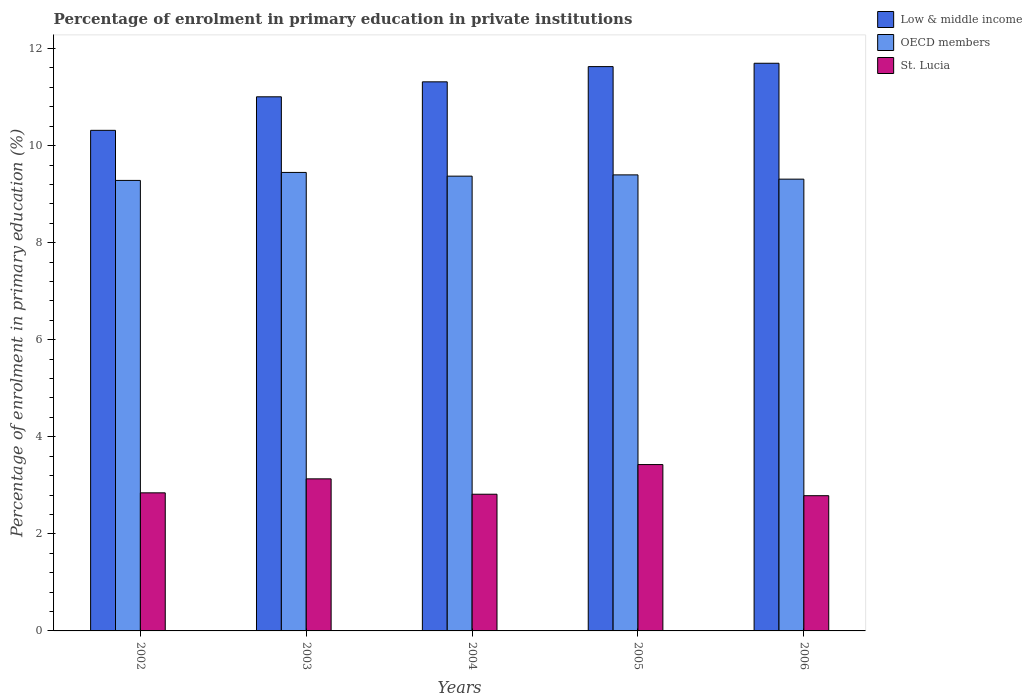How many different coloured bars are there?
Your answer should be very brief. 3. How many groups of bars are there?
Keep it short and to the point. 5. How many bars are there on the 1st tick from the left?
Your answer should be compact. 3. What is the label of the 2nd group of bars from the left?
Offer a very short reply. 2003. In how many cases, is the number of bars for a given year not equal to the number of legend labels?
Provide a succinct answer. 0. What is the percentage of enrolment in primary education in St. Lucia in 2004?
Your answer should be very brief. 2.82. Across all years, what is the maximum percentage of enrolment in primary education in OECD members?
Ensure brevity in your answer.  9.45. Across all years, what is the minimum percentage of enrolment in primary education in Low & middle income?
Your answer should be very brief. 10.31. What is the total percentage of enrolment in primary education in St. Lucia in the graph?
Make the answer very short. 15.01. What is the difference between the percentage of enrolment in primary education in OECD members in 2003 and that in 2006?
Give a very brief answer. 0.14. What is the difference between the percentage of enrolment in primary education in Low & middle income in 2003 and the percentage of enrolment in primary education in St. Lucia in 2005?
Keep it short and to the point. 7.58. What is the average percentage of enrolment in primary education in OECD members per year?
Your answer should be very brief. 9.36. In the year 2003, what is the difference between the percentage of enrolment in primary education in OECD members and percentage of enrolment in primary education in St. Lucia?
Provide a succinct answer. 6.31. In how many years, is the percentage of enrolment in primary education in Low & middle income greater than 7.2 %?
Your response must be concise. 5. What is the ratio of the percentage of enrolment in primary education in Low & middle income in 2004 to that in 2005?
Give a very brief answer. 0.97. Is the percentage of enrolment in primary education in Low & middle income in 2002 less than that in 2005?
Keep it short and to the point. Yes. What is the difference between the highest and the second highest percentage of enrolment in primary education in Low & middle income?
Your answer should be very brief. 0.07. What is the difference between the highest and the lowest percentage of enrolment in primary education in OECD members?
Provide a succinct answer. 0.16. In how many years, is the percentage of enrolment in primary education in St. Lucia greater than the average percentage of enrolment in primary education in St. Lucia taken over all years?
Ensure brevity in your answer.  2. What does the 3rd bar from the left in 2003 represents?
Offer a terse response. St. Lucia. Is it the case that in every year, the sum of the percentage of enrolment in primary education in St. Lucia and percentage of enrolment in primary education in Low & middle income is greater than the percentage of enrolment in primary education in OECD members?
Give a very brief answer. Yes. How many bars are there?
Provide a succinct answer. 15. How many years are there in the graph?
Offer a very short reply. 5. What is the difference between two consecutive major ticks on the Y-axis?
Ensure brevity in your answer.  2. Does the graph contain grids?
Offer a terse response. No. Where does the legend appear in the graph?
Make the answer very short. Top right. How are the legend labels stacked?
Provide a succinct answer. Vertical. What is the title of the graph?
Your answer should be very brief. Percentage of enrolment in primary education in private institutions. Does "Somalia" appear as one of the legend labels in the graph?
Give a very brief answer. No. What is the label or title of the Y-axis?
Provide a short and direct response. Percentage of enrolment in primary education (%). What is the Percentage of enrolment in primary education (%) of Low & middle income in 2002?
Your response must be concise. 10.31. What is the Percentage of enrolment in primary education (%) in OECD members in 2002?
Offer a terse response. 9.28. What is the Percentage of enrolment in primary education (%) of St. Lucia in 2002?
Offer a terse response. 2.85. What is the Percentage of enrolment in primary education (%) in Low & middle income in 2003?
Provide a short and direct response. 11.01. What is the Percentage of enrolment in primary education (%) in OECD members in 2003?
Offer a terse response. 9.45. What is the Percentage of enrolment in primary education (%) in St. Lucia in 2003?
Ensure brevity in your answer.  3.13. What is the Percentage of enrolment in primary education (%) in Low & middle income in 2004?
Your answer should be very brief. 11.31. What is the Percentage of enrolment in primary education (%) in OECD members in 2004?
Your response must be concise. 9.37. What is the Percentage of enrolment in primary education (%) in St. Lucia in 2004?
Give a very brief answer. 2.82. What is the Percentage of enrolment in primary education (%) in Low & middle income in 2005?
Give a very brief answer. 11.63. What is the Percentage of enrolment in primary education (%) of OECD members in 2005?
Provide a succinct answer. 9.4. What is the Percentage of enrolment in primary education (%) of St. Lucia in 2005?
Your answer should be compact. 3.43. What is the Percentage of enrolment in primary education (%) of Low & middle income in 2006?
Give a very brief answer. 11.7. What is the Percentage of enrolment in primary education (%) in OECD members in 2006?
Your answer should be compact. 9.31. What is the Percentage of enrolment in primary education (%) in St. Lucia in 2006?
Ensure brevity in your answer.  2.79. Across all years, what is the maximum Percentage of enrolment in primary education (%) of Low & middle income?
Ensure brevity in your answer.  11.7. Across all years, what is the maximum Percentage of enrolment in primary education (%) in OECD members?
Your answer should be very brief. 9.45. Across all years, what is the maximum Percentage of enrolment in primary education (%) of St. Lucia?
Give a very brief answer. 3.43. Across all years, what is the minimum Percentage of enrolment in primary education (%) of Low & middle income?
Offer a very short reply. 10.31. Across all years, what is the minimum Percentage of enrolment in primary education (%) of OECD members?
Offer a very short reply. 9.28. Across all years, what is the minimum Percentage of enrolment in primary education (%) of St. Lucia?
Your response must be concise. 2.79. What is the total Percentage of enrolment in primary education (%) of Low & middle income in the graph?
Make the answer very short. 55.96. What is the total Percentage of enrolment in primary education (%) in OECD members in the graph?
Give a very brief answer. 46.81. What is the total Percentage of enrolment in primary education (%) in St. Lucia in the graph?
Your response must be concise. 15.01. What is the difference between the Percentage of enrolment in primary education (%) of Low & middle income in 2002 and that in 2003?
Your answer should be very brief. -0.69. What is the difference between the Percentage of enrolment in primary education (%) in OECD members in 2002 and that in 2003?
Your answer should be compact. -0.16. What is the difference between the Percentage of enrolment in primary education (%) of St. Lucia in 2002 and that in 2003?
Your response must be concise. -0.29. What is the difference between the Percentage of enrolment in primary education (%) of Low & middle income in 2002 and that in 2004?
Provide a short and direct response. -1. What is the difference between the Percentage of enrolment in primary education (%) of OECD members in 2002 and that in 2004?
Your response must be concise. -0.09. What is the difference between the Percentage of enrolment in primary education (%) of St. Lucia in 2002 and that in 2004?
Ensure brevity in your answer.  0.03. What is the difference between the Percentage of enrolment in primary education (%) in Low & middle income in 2002 and that in 2005?
Your answer should be compact. -1.31. What is the difference between the Percentage of enrolment in primary education (%) in OECD members in 2002 and that in 2005?
Offer a very short reply. -0.11. What is the difference between the Percentage of enrolment in primary education (%) in St. Lucia in 2002 and that in 2005?
Give a very brief answer. -0.58. What is the difference between the Percentage of enrolment in primary education (%) of Low & middle income in 2002 and that in 2006?
Your answer should be compact. -1.38. What is the difference between the Percentage of enrolment in primary education (%) in OECD members in 2002 and that in 2006?
Offer a terse response. -0.03. What is the difference between the Percentage of enrolment in primary education (%) in St. Lucia in 2002 and that in 2006?
Ensure brevity in your answer.  0.06. What is the difference between the Percentage of enrolment in primary education (%) of Low & middle income in 2003 and that in 2004?
Provide a short and direct response. -0.31. What is the difference between the Percentage of enrolment in primary education (%) in OECD members in 2003 and that in 2004?
Make the answer very short. 0.08. What is the difference between the Percentage of enrolment in primary education (%) in St. Lucia in 2003 and that in 2004?
Keep it short and to the point. 0.32. What is the difference between the Percentage of enrolment in primary education (%) in Low & middle income in 2003 and that in 2005?
Your response must be concise. -0.62. What is the difference between the Percentage of enrolment in primary education (%) in OECD members in 2003 and that in 2005?
Provide a short and direct response. 0.05. What is the difference between the Percentage of enrolment in primary education (%) of St. Lucia in 2003 and that in 2005?
Your answer should be very brief. -0.29. What is the difference between the Percentage of enrolment in primary education (%) of Low & middle income in 2003 and that in 2006?
Keep it short and to the point. -0.69. What is the difference between the Percentage of enrolment in primary education (%) in OECD members in 2003 and that in 2006?
Give a very brief answer. 0.14. What is the difference between the Percentage of enrolment in primary education (%) in St. Lucia in 2003 and that in 2006?
Your answer should be compact. 0.35. What is the difference between the Percentage of enrolment in primary education (%) in Low & middle income in 2004 and that in 2005?
Provide a succinct answer. -0.31. What is the difference between the Percentage of enrolment in primary education (%) of OECD members in 2004 and that in 2005?
Give a very brief answer. -0.03. What is the difference between the Percentage of enrolment in primary education (%) in St. Lucia in 2004 and that in 2005?
Ensure brevity in your answer.  -0.61. What is the difference between the Percentage of enrolment in primary education (%) of Low & middle income in 2004 and that in 2006?
Your answer should be compact. -0.38. What is the difference between the Percentage of enrolment in primary education (%) in OECD members in 2004 and that in 2006?
Keep it short and to the point. 0.06. What is the difference between the Percentage of enrolment in primary education (%) of St. Lucia in 2004 and that in 2006?
Your response must be concise. 0.03. What is the difference between the Percentage of enrolment in primary education (%) of Low & middle income in 2005 and that in 2006?
Your answer should be compact. -0.07. What is the difference between the Percentage of enrolment in primary education (%) of OECD members in 2005 and that in 2006?
Keep it short and to the point. 0.09. What is the difference between the Percentage of enrolment in primary education (%) in St. Lucia in 2005 and that in 2006?
Offer a terse response. 0.64. What is the difference between the Percentage of enrolment in primary education (%) in Low & middle income in 2002 and the Percentage of enrolment in primary education (%) in OECD members in 2003?
Make the answer very short. 0.87. What is the difference between the Percentage of enrolment in primary education (%) of Low & middle income in 2002 and the Percentage of enrolment in primary education (%) of St. Lucia in 2003?
Offer a terse response. 7.18. What is the difference between the Percentage of enrolment in primary education (%) in OECD members in 2002 and the Percentage of enrolment in primary education (%) in St. Lucia in 2003?
Keep it short and to the point. 6.15. What is the difference between the Percentage of enrolment in primary education (%) in Low & middle income in 2002 and the Percentage of enrolment in primary education (%) in OECD members in 2004?
Give a very brief answer. 0.94. What is the difference between the Percentage of enrolment in primary education (%) of Low & middle income in 2002 and the Percentage of enrolment in primary education (%) of St. Lucia in 2004?
Provide a succinct answer. 7.5. What is the difference between the Percentage of enrolment in primary education (%) in OECD members in 2002 and the Percentage of enrolment in primary education (%) in St. Lucia in 2004?
Offer a very short reply. 6.47. What is the difference between the Percentage of enrolment in primary education (%) in Low & middle income in 2002 and the Percentage of enrolment in primary education (%) in OECD members in 2005?
Your answer should be very brief. 0.92. What is the difference between the Percentage of enrolment in primary education (%) of Low & middle income in 2002 and the Percentage of enrolment in primary education (%) of St. Lucia in 2005?
Your answer should be very brief. 6.89. What is the difference between the Percentage of enrolment in primary education (%) in OECD members in 2002 and the Percentage of enrolment in primary education (%) in St. Lucia in 2005?
Make the answer very short. 5.86. What is the difference between the Percentage of enrolment in primary education (%) of Low & middle income in 2002 and the Percentage of enrolment in primary education (%) of OECD members in 2006?
Give a very brief answer. 1.01. What is the difference between the Percentage of enrolment in primary education (%) in Low & middle income in 2002 and the Percentage of enrolment in primary education (%) in St. Lucia in 2006?
Offer a very short reply. 7.53. What is the difference between the Percentage of enrolment in primary education (%) in OECD members in 2002 and the Percentage of enrolment in primary education (%) in St. Lucia in 2006?
Keep it short and to the point. 6.5. What is the difference between the Percentage of enrolment in primary education (%) in Low & middle income in 2003 and the Percentage of enrolment in primary education (%) in OECD members in 2004?
Provide a succinct answer. 1.63. What is the difference between the Percentage of enrolment in primary education (%) in Low & middle income in 2003 and the Percentage of enrolment in primary education (%) in St. Lucia in 2004?
Offer a terse response. 8.19. What is the difference between the Percentage of enrolment in primary education (%) in OECD members in 2003 and the Percentage of enrolment in primary education (%) in St. Lucia in 2004?
Ensure brevity in your answer.  6.63. What is the difference between the Percentage of enrolment in primary education (%) in Low & middle income in 2003 and the Percentage of enrolment in primary education (%) in OECD members in 2005?
Keep it short and to the point. 1.61. What is the difference between the Percentage of enrolment in primary education (%) of Low & middle income in 2003 and the Percentage of enrolment in primary education (%) of St. Lucia in 2005?
Keep it short and to the point. 7.58. What is the difference between the Percentage of enrolment in primary education (%) in OECD members in 2003 and the Percentage of enrolment in primary education (%) in St. Lucia in 2005?
Keep it short and to the point. 6.02. What is the difference between the Percentage of enrolment in primary education (%) of Low & middle income in 2003 and the Percentage of enrolment in primary education (%) of OECD members in 2006?
Keep it short and to the point. 1.7. What is the difference between the Percentage of enrolment in primary education (%) in Low & middle income in 2003 and the Percentage of enrolment in primary education (%) in St. Lucia in 2006?
Offer a very short reply. 8.22. What is the difference between the Percentage of enrolment in primary education (%) of OECD members in 2003 and the Percentage of enrolment in primary education (%) of St. Lucia in 2006?
Your answer should be very brief. 6.66. What is the difference between the Percentage of enrolment in primary education (%) in Low & middle income in 2004 and the Percentage of enrolment in primary education (%) in OECD members in 2005?
Ensure brevity in your answer.  1.92. What is the difference between the Percentage of enrolment in primary education (%) of Low & middle income in 2004 and the Percentage of enrolment in primary education (%) of St. Lucia in 2005?
Your response must be concise. 7.89. What is the difference between the Percentage of enrolment in primary education (%) in OECD members in 2004 and the Percentage of enrolment in primary education (%) in St. Lucia in 2005?
Make the answer very short. 5.94. What is the difference between the Percentage of enrolment in primary education (%) of Low & middle income in 2004 and the Percentage of enrolment in primary education (%) of OECD members in 2006?
Provide a succinct answer. 2. What is the difference between the Percentage of enrolment in primary education (%) of Low & middle income in 2004 and the Percentage of enrolment in primary education (%) of St. Lucia in 2006?
Provide a short and direct response. 8.53. What is the difference between the Percentage of enrolment in primary education (%) of OECD members in 2004 and the Percentage of enrolment in primary education (%) of St. Lucia in 2006?
Provide a succinct answer. 6.58. What is the difference between the Percentage of enrolment in primary education (%) of Low & middle income in 2005 and the Percentage of enrolment in primary education (%) of OECD members in 2006?
Give a very brief answer. 2.32. What is the difference between the Percentage of enrolment in primary education (%) in Low & middle income in 2005 and the Percentage of enrolment in primary education (%) in St. Lucia in 2006?
Give a very brief answer. 8.84. What is the difference between the Percentage of enrolment in primary education (%) of OECD members in 2005 and the Percentage of enrolment in primary education (%) of St. Lucia in 2006?
Ensure brevity in your answer.  6.61. What is the average Percentage of enrolment in primary education (%) of Low & middle income per year?
Your answer should be very brief. 11.19. What is the average Percentage of enrolment in primary education (%) in OECD members per year?
Give a very brief answer. 9.36. What is the average Percentage of enrolment in primary education (%) in St. Lucia per year?
Provide a succinct answer. 3. In the year 2002, what is the difference between the Percentage of enrolment in primary education (%) of Low & middle income and Percentage of enrolment in primary education (%) of OECD members?
Your answer should be compact. 1.03. In the year 2002, what is the difference between the Percentage of enrolment in primary education (%) in Low & middle income and Percentage of enrolment in primary education (%) in St. Lucia?
Offer a terse response. 7.47. In the year 2002, what is the difference between the Percentage of enrolment in primary education (%) in OECD members and Percentage of enrolment in primary education (%) in St. Lucia?
Offer a very short reply. 6.44. In the year 2003, what is the difference between the Percentage of enrolment in primary education (%) in Low & middle income and Percentage of enrolment in primary education (%) in OECD members?
Your response must be concise. 1.56. In the year 2003, what is the difference between the Percentage of enrolment in primary education (%) of Low & middle income and Percentage of enrolment in primary education (%) of St. Lucia?
Give a very brief answer. 7.87. In the year 2003, what is the difference between the Percentage of enrolment in primary education (%) in OECD members and Percentage of enrolment in primary education (%) in St. Lucia?
Ensure brevity in your answer.  6.31. In the year 2004, what is the difference between the Percentage of enrolment in primary education (%) in Low & middle income and Percentage of enrolment in primary education (%) in OECD members?
Provide a short and direct response. 1.94. In the year 2004, what is the difference between the Percentage of enrolment in primary education (%) in Low & middle income and Percentage of enrolment in primary education (%) in St. Lucia?
Make the answer very short. 8.5. In the year 2004, what is the difference between the Percentage of enrolment in primary education (%) of OECD members and Percentage of enrolment in primary education (%) of St. Lucia?
Ensure brevity in your answer.  6.55. In the year 2005, what is the difference between the Percentage of enrolment in primary education (%) in Low & middle income and Percentage of enrolment in primary education (%) in OECD members?
Make the answer very short. 2.23. In the year 2005, what is the difference between the Percentage of enrolment in primary education (%) in Low & middle income and Percentage of enrolment in primary education (%) in St. Lucia?
Your answer should be compact. 8.2. In the year 2005, what is the difference between the Percentage of enrolment in primary education (%) in OECD members and Percentage of enrolment in primary education (%) in St. Lucia?
Provide a short and direct response. 5.97. In the year 2006, what is the difference between the Percentage of enrolment in primary education (%) of Low & middle income and Percentage of enrolment in primary education (%) of OECD members?
Ensure brevity in your answer.  2.39. In the year 2006, what is the difference between the Percentage of enrolment in primary education (%) of Low & middle income and Percentage of enrolment in primary education (%) of St. Lucia?
Your answer should be compact. 8.91. In the year 2006, what is the difference between the Percentage of enrolment in primary education (%) in OECD members and Percentage of enrolment in primary education (%) in St. Lucia?
Offer a terse response. 6.52. What is the ratio of the Percentage of enrolment in primary education (%) of Low & middle income in 2002 to that in 2003?
Your answer should be very brief. 0.94. What is the ratio of the Percentage of enrolment in primary education (%) in OECD members in 2002 to that in 2003?
Your answer should be very brief. 0.98. What is the ratio of the Percentage of enrolment in primary education (%) in St. Lucia in 2002 to that in 2003?
Give a very brief answer. 0.91. What is the ratio of the Percentage of enrolment in primary education (%) in Low & middle income in 2002 to that in 2004?
Make the answer very short. 0.91. What is the ratio of the Percentage of enrolment in primary education (%) of OECD members in 2002 to that in 2004?
Make the answer very short. 0.99. What is the ratio of the Percentage of enrolment in primary education (%) in Low & middle income in 2002 to that in 2005?
Provide a short and direct response. 0.89. What is the ratio of the Percentage of enrolment in primary education (%) in OECD members in 2002 to that in 2005?
Ensure brevity in your answer.  0.99. What is the ratio of the Percentage of enrolment in primary education (%) of St. Lucia in 2002 to that in 2005?
Make the answer very short. 0.83. What is the ratio of the Percentage of enrolment in primary education (%) of Low & middle income in 2002 to that in 2006?
Provide a succinct answer. 0.88. What is the ratio of the Percentage of enrolment in primary education (%) in OECD members in 2002 to that in 2006?
Provide a succinct answer. 1. What is the ratio of the Percentage of enrolment in primary education (%) in St. Lucia in 2002 to that in 2006?
Offer a very short reply. 1.02. What is the ratio of the Percentage of enrolment in primary education (%) in Low & middle income in 2003 to that in 2004?
Your response must be concise. 0.97. What is the ratio of the Percentage of enrolment in primary education (%) of OECD members in 2003 to that in 2004?
Offer a very short reply. 1.01. What is the ratio of the Percentage of enrolment in primary education (%) of St. Lucia in 2003 to that in 2004?
Your answer should be very brief. 1.11. What is the ratio of the Percentage of enrolment in primary education (%) in Low & middle income in 2003 to that in 2005?
Your answer should be compact. 0.95. What is the ratio of the Percentage of enrolment in primary education (%) of OECD members in 2003 to that in 2005?
Offer a very short reply. 1.01. What is the ratio of the Percentage of enrolment in primary education (%) in St. Lucia in 2003 to that in 2005?
Ensure brevity in your answer.  0.91. What is the ratio of the Percentage of enrolment in primary education (%) in Low & middle income in 2003 to that in 2006?
Your answer should be very brief. 0.94. What is the ratio of the Percentage of enrolment in primary education (%) of OECD members in 2003 to that in 2006?
Keep it short and to the point. 1.01. What is the ratio of the Percentage of enrolment in primary education (%) of St. Lucia in 2003 to that in 2006?
Provide a short and direct response. 1.12. What is the ratio of the Percentage of enrolment in primary education (%) of OECD members in 2004 to that in 2005?
Provide a short and direct response. 1. What is the ratio of the Percentage of enrolment in primary education (%) of St. Lucia in 2004 to that in 2005?
Your answer should be very brief. 0.82. What is the ratio of the Percentage of enrolment in primary education (%) of Low & middle income in 2004 to that in 2006?
Offer a very short reply. 0.97. What is the ratio of the Percentage of enrolment in primary education (%) of OECD members in 2004 to that in 2006?
Give a very brief answer. 1.01. What is the ratio of the Percentage of enrolment in primary education (%) in St. Lucia in 2004 to that in 2006?
Provide a succinct answer. 1.01. What is the ratio of the Percentage of enrolment in primary education (%) of Low & middle income in 2005 to that in 2006?
Offer a terse response. 0.99. What is the ratio of the Percentage of enrolment in primary education (%) of OECD members in 2005 to that in 2006?
Provide a succinct answer. 1.01. What is the ratio of the Percentage of enrolment in primary education (%) in St. Lucia in 2005 to that in 2006?
Give a very brief answer. 1.23. What is the difference between the highest and the second highest Percentage of enrolment in primary education (%) of Low & middle income?
Provide a short and direct response. 0.07. What is the difference between the highest and the second highest Percentage of enrolment in primary education (%) of OECD members?
Make the answer very short. 0.05. What is the difference between the highest and the second highest Percentage of enrolment in primary education (%) in St. Lucia?
Your answer should be compact. 0.29. What is the difference between the highest and the lowest Percentage of enrolment in primary education (%) of Low & middle income?
Ensure brevity in your answer.  1.38. What is the difference between the highest and the lowest Percentage of enrolment in primary education (%) of OECD members?
Provide a short and direct response. 0.16. What is the difference between the highest and the lowest Percentage of enrolment in primary education (%) of St. Lucia?
Make the answer very short. 0.64. 